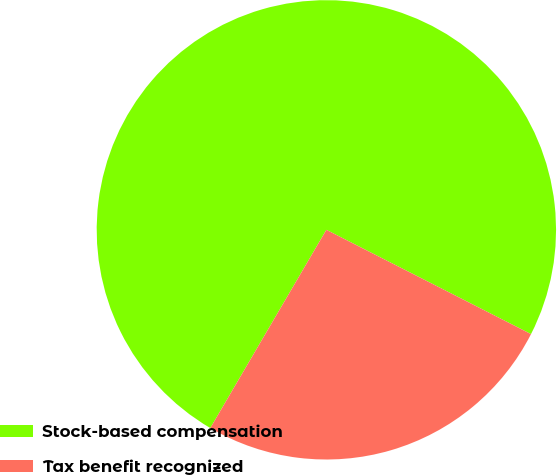Convert chart to OTSL. <chart><loc_0><loc_0><loc_500><loc_500><pie_chart><fcel>Stock-based compensation<fcel>Tax benefit recognized<nl><fcel>74.07%<fcel>25.93%<nl></chart> 